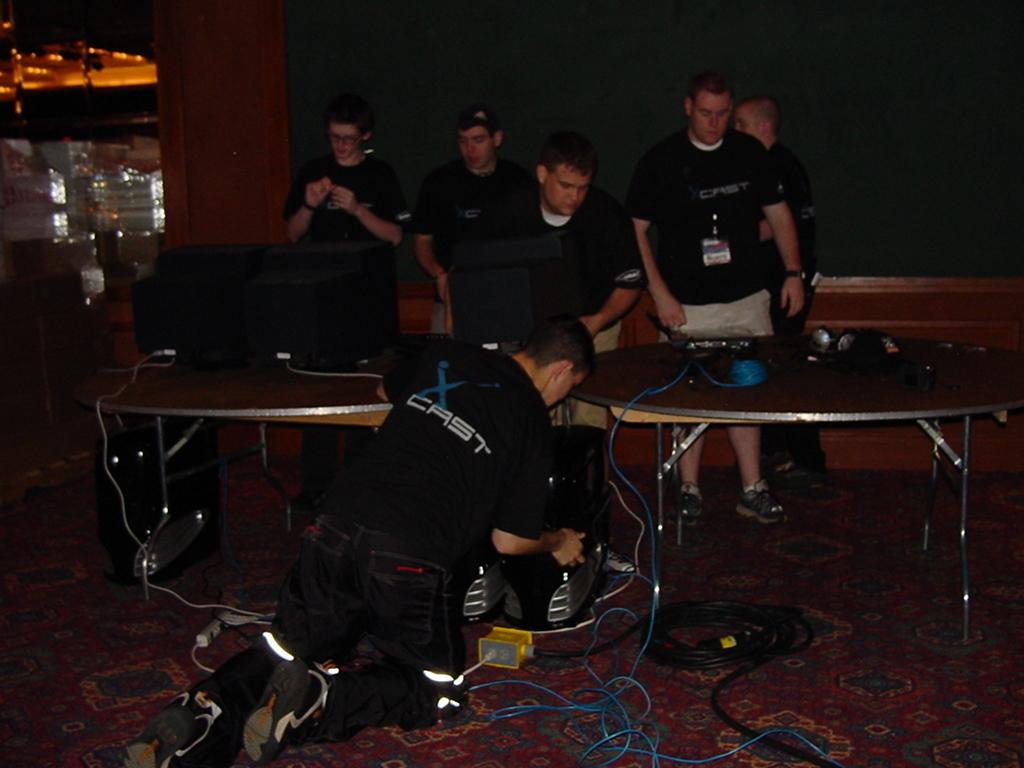Can you describe this image briefly? Here there are people standing and a person is standing on his knees. There are 2 tables here. On the table we can see headphones and some electronic devices. There are cables on the floor. 